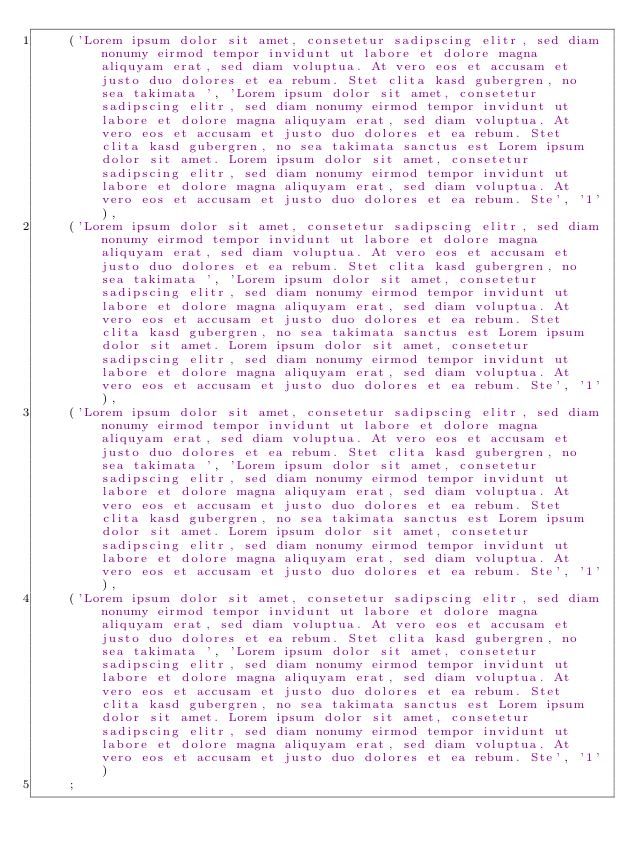<code> <loc_0><loc_0><loc_500><loc_500><_SQL_>    ('Lorem ipsum dolor sit amet, consetetur sadipscing elitr, sed diam nonumy eirmod tempor invidunt ut labore et dolore magna aliquyam erat, sed diam voluptua. At vero eos et accusam et justo duo dolores et ea rebum. Stet clita kasd gubergren, no sea takimata ', 'Lorem ipsum dolor sit amet, consetetur sadipscing elitr, sed diam nonumy eirmod tempor invidunt ut labore et dolore magna aliquyam erat, sed diam voluptua. At vero eos et accusam et justo duo dolores et ea rebum. Stet clita kasd gubergren, no sea takimata sanctus est Lorem ipsum dolor sit amet. Lorem ipsum dolor sit amet, consetetur sadipscing elitr, sed diam nonumy eirmod tempor invidunt ut labore et dolore magna aliquyam erat, sed diam voluptua. At vero eos et accusam et justo duo dolores et ea rebum. Ste', '1'),
    ('Lorem ipsum dolor sit amet, consetetur sadipscing elitr, sed diam nonumy eirmod tempor invidunt ut labore et dolore magna aliquyam erat, sed diam voluptua. At vero eos et accusam et justo duo dolores et ea rebum. Stet clita kasd gubergren, no sea takimata ', 'Lorem ipsum dolor sit amet, consetetur sadipscing elitr, sed diam nonumy eirmod tempor invidunt ut labore et dolore magna aliquyam erat, sed diam voluptua. At vero eos et accusam et justo duo dolores et ea rebum. Stet clita kasd gubergren, no sea takimata sanctus est Lorem ipsum dolor sit amet. Lorem ipsum dolor sit amet, consetetur sadipscing elitr, sed diam nonumy eirmod tempor invidunt ut labore et dolore magna aliquyam erat, sed diam voluptua. At vero eos et accusam et justo duo dolores et ea rebum. Ste', '1'),
    ('Lorem ipsum dolor sit amet, consetetur sadipscing elitr, sed diam nonumy eirmod tempor invidunt ut labore et dolore magna aliquyam erat, sed diam voluptua. At vero eos et accusam et justo duo dolores et ea rebum. Stet clita kasd gubergren, no sea takimata ', 'Lorem ipsum dolor sit amet, consetetur sadipscing elitr, sed diam nonumy eirmod tempor invidunt ut labore et dolore magna aliquyam erat, sed diam voluptua. At vero eos et accusam et justo duo dolores et ea rebum. Stet clita kasd gubergren, no sea takimata sanctus est Lorem ipsum dolor sit amet. Lorem ipsum dolor sit amet, consetetur sadipscing elitr, sed diam nonumy eirmod tempor invidunt ut labore et dolore magna aliquyam erat, sed diam voluptua. At vero eos et accusam et justo duo dolores et ea rebum. Ste', '1'),
    ('Lorem ipsum dolor sit amet, consetetur sadipscing elitr, sed diam nonumy eirmod tempor invidunt ut labore et dolore magna aliquyam erat, sed diam voluptua. At vero eos et accusam et justo duo dolores et ea rebum. Stet clita kasd gubergren, no sea takimata ', 'Lorem ipsum dolor sit amet, consetetur sadipscing elitr, sed diam nonumy eirmod tempor invidunt ut labore et dolore magna aliquyam erat, sed diam voluptua. At vero eos et accusam et justo duo dolores et ea rebum. Stet clita kasd gubergren, no sea takimata sanctus est Lorem ipsum dolor sit amet. Lorem ipsum dolor sit amet, consetetur sadipscing elitr, sed diam nonumy eirmod tempor invidunt ut labore et dolore magna aliquyam erat, sed diam voluptua. At vero eos et accusam et justo duo dolores et ea rebum. Ste', '1')
    ;</code> 